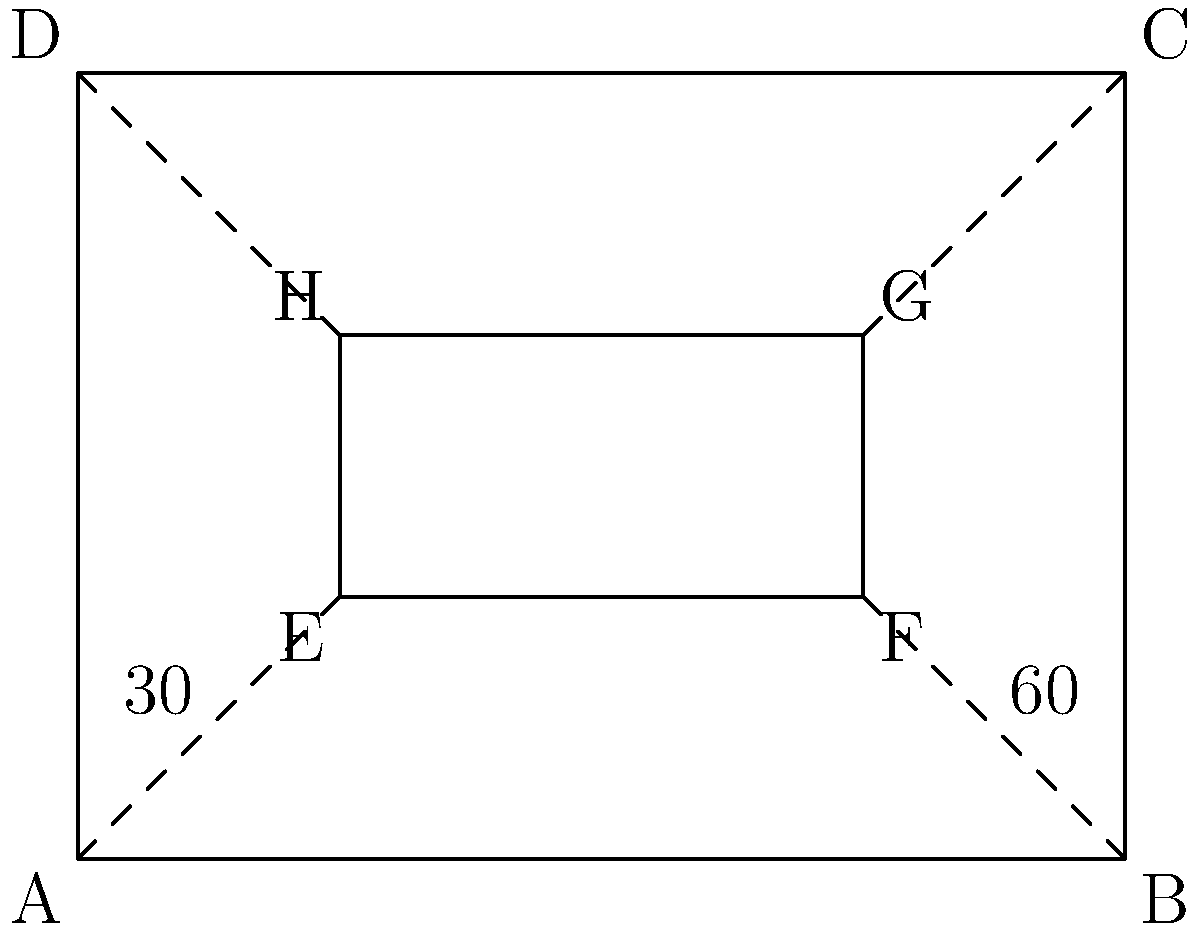In a popular Tamil TV show's studio set, the main stage EFGH is positioned inside a larger rectangular area ABCD, as shown in the diagram. The angle between AE and AB is 30°, while the angle between BF and BA is 60°. If the studio manager wants to ensure that the stage is perfectly centered, what should be the measure of angle DCG? Let's approach this step-by-step:

1) In a rectangle, all angles are 90°. So, angle DAB = 90°.

2) We're given that angle EAB = 30° and angle FBA = 60°.

3) In triangle AEB:
   - Angle AEB = 90° (since EFGH is a rectangle)
   - Angle EAB = 30°
   - Therefore, angle ABE = 180° - 90° - 30° = 60°

4) Now, we can see that triangles AEB and DCG are similar:
   - They both have a right angle (at E and G respectively)
   - They share the same angle at B and C (alternate angles)

5) Since these triangles are similar, their corresponding angles are equal.

6) We found that angle ABE = 60°, so its corresponding angle in triangle DCG, which is angle DCG, must also be 60°.

7) This makes sense geometrically, as it ensures that the inner rectangle EFGH is centered within ABCD.
Answer: 60° 